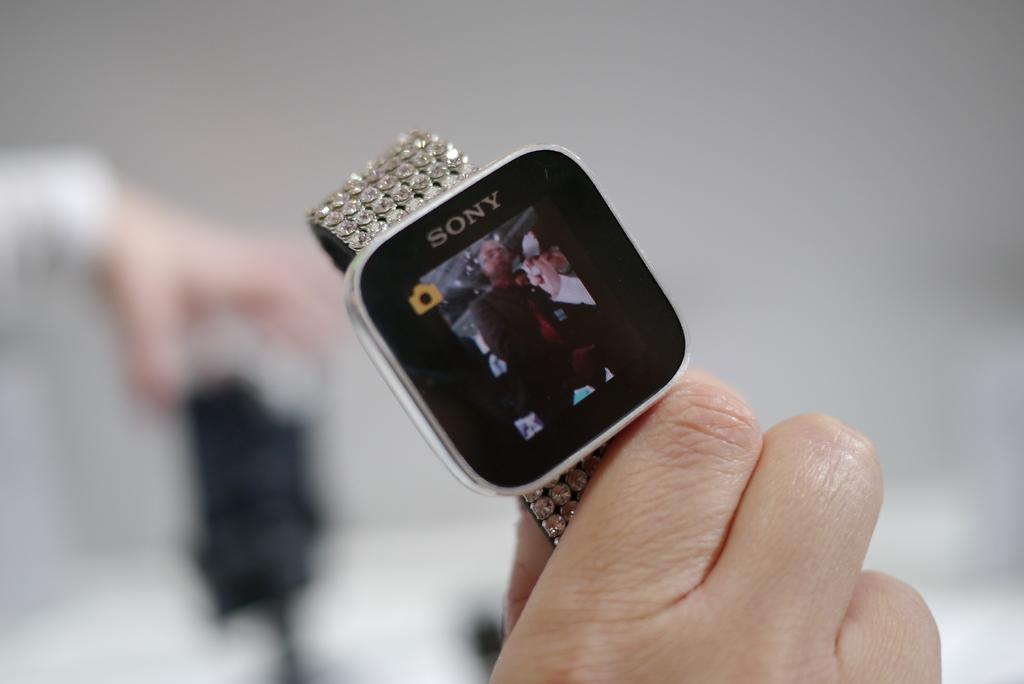<image>
Write a terse but informative summary of the picture. Sony smart watch with video and camera capability, has bejeweled straps set in like sequins. 